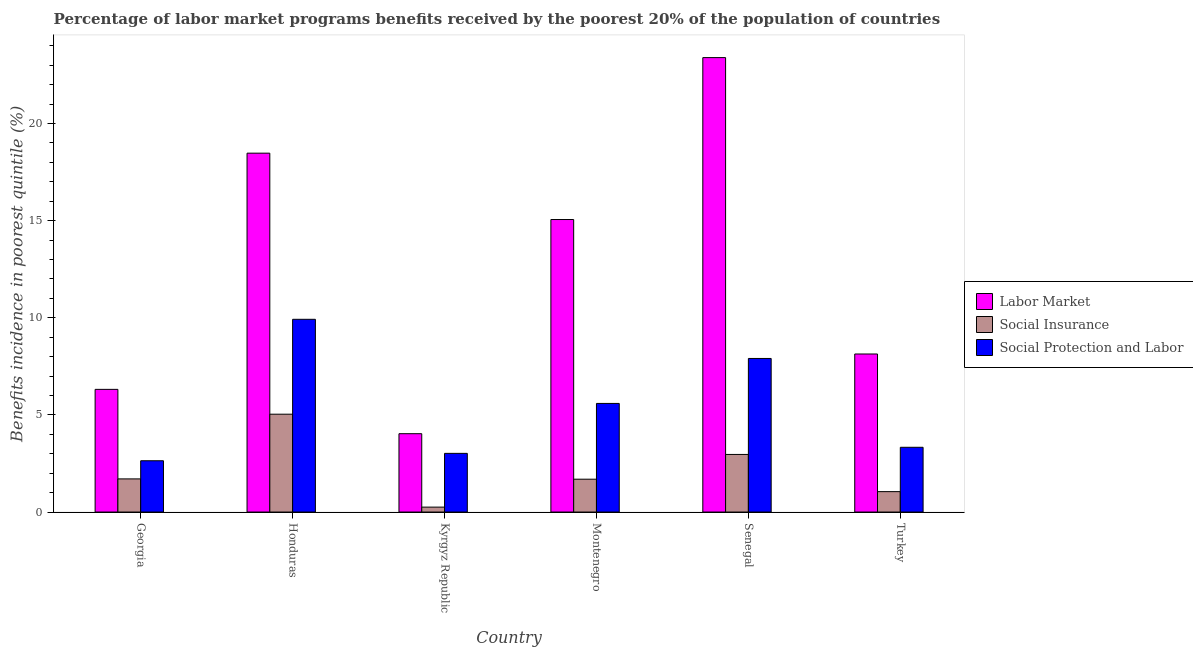Are the number of bars per tick equal to the number of legend labels?
Make the answer very short. Yes. Are the number of bars on each tick of the X-axis equal?
Keep it short and to the point. Yes. How many bars are there on the 5th tick from the right?
Keep it short and to the point. 3. What is the label of the 3rd group of bars from the left?
Offer a terse response. Kyrgyz Republic. In how many cases, is the number of bars for a given country not equal to the number of legend labels?
Ensure brevity in your answer.  0. What is the percentage of benefits received due to social protection programs in Montenegro?
Give a very brief answer. 5.59. Across all countries, what is the maximum percentage of benefits received due to labor market programs?
Offer a terse response. 23.39. Across all countries, what is the minimum percentage of benefits received due to social protection programs?
Give a very brief answer. 2.64. In which country was the percentage of benefits received due to labor market programs maximum?
Your answer should be very brief. Senegal. In which country was the percentage of benefits received due to social insurance programs minimum?
Provide a short and direct response. Kyrgyz Republic. What is the total percentage of benefits received due to labor market programs in the graph?
Keep it short and to the point. 75.39. What is the difference between the percentage of benefits received due to social insurance programs in Georgia and that in Senegal?
Your response must be concise. -1.26. What is the difference between the percentage of benefits received due to labor market programs in Georgia and the percentage of benefits received due to social protection programs in Kyrgyz Republic?
Offer a terse response. 3.29. What is the average percentage of benefits received due to social protection programs per country?
Ensure brevity in your answer.  5.4. What is the difference between the percentage of benefits received due to labor market programs and percentage of benefits received due to social protection programs in Honduras?
Your answer should be very brief. 8.55. What is the ratio of the percentage of benefits received due to social insurance programs in Honduras to that in Turkey?
Offer a terse response. 4.8. Is the percentage of benefits received due to labor market programs in Montenegro less than that in Senegal?
Give a very brief answer. Yes. What is the difference between the highest and the second highest percentage of benefits received due to labor market programs?
Your answer should be very brief. 4.92. What is the difference between the highest and the lowest percentage of benefits received due to social protection programs?
Your response must be concise. 7.28. What does the 1st bar from the left in Honduras represents?
Offer a very short reply. Labor Market. What does the 3rd bar from the right in Kyrgyz Republic represents?
Provide a short and direct response. Labor Market. Is it the case that in every country, the sum of the percentage of benefits received due to labor market programs and percentage of benefits received due to social insurance programs is greater than the percentage of benefits received due to social protection programs?
Give a very brief answer. Yes. How many countries are there in the graph?
Provide a succinct answer. 6. Are the values on the major ticks of Y-axis written in scientific E-notation?
Offer a terse response. No. Does the graph contain any zero values?
Provide a succinct answer. No. Does the graph contain grids?
Provide a succinct answer. No. Where does the legend appear in the graph?
Offer a terse response. Center right. How are the legend labels stacked?
Provide a short and direct response. Vertical. What is the title of the graph?
Provide a short and direct response. Percentage of labor market programs benefits received by the poorest 20% of the population of countries. Does "Agriculture" appear as one of the legend labels in the graph?
Provide a short and direct response. No. What is the label or title of the X-axis?
Your answer should be very brief. Country. What is the label or title of the Y-axis?
Give a very brief answer. Benefits incidence in poorest quintile (%). What is the Benefits incidence in poorest quintile (%) of Labor Market in Georgia?
Give a very brief answer. 6.31. What is the Benefits incidence in poorest quintile (%) of Social Insurance in Georgia?
Make the answer very short. 1.71. What is the Benefits incidence in poorest quintile (%) in Social Protection and Labor in Georgia?
Offer a terse response. 2.64. What is the Benefits incidence in poorest quintile (%) in Labor Market in Honduras?
Ensure brevity in your answer.  18.47. What is the Benefits incidence in poorest quintile (%) in Social Insurance in Honduras?
Make the answer very short. 5.04. What is the Benefits incidence in poorest quintile (%) of Social Protection and Labor in Honduras?
Ensure brevity in your answer.  9.92. What is the Benefits incidence in poorest quintile (%) of Labor Market in Kyrgyz Republic?
Your answer should be compact. 4.03. What is the Benefits incidence in poorest quintile (%) in Social Insurance in Kyrgyz Republic?
Your response must be concise. 0.25. What is the Benefits incidence in poorest quintile (%) in Social Protection and Labor in Kyrgyz Republic?
Ensure brevity in your answer.  3.02. What is the Benefits incidence in poorest quintile (%) of Labor Market in Montenegro?
Keep it short and to the point. 15.05. What is the Benefits incidence in poorest quintile (%) in Social Insurance in Montenegro?
Your answer should be very brief. 1.69. What is the Benefits incidence in poorest quintile (%) of Social Protection and Labor in Montenegro?
Your answer should be compact. 5.59. What is the Benefits incidence in poorest quintile (%) of Labor Market in Senegal?
Keep it short and to the point. 23.39. What is the Benefits incidence in poorest quintile (%) of Social Insurance in Senegal?
Your response must be concise. 2.96. What is the Benefits incidence in poorest quintile (%) of Social Protection and Labor in Senegal?
Your answer should be very brief. 7.9. What is the Benefits incidence in poorest quintile (%) in Labor Market in Turkey?
Provide a succinct answer. 8.13. What is the Benefits incidence in poorest quintile (%) of Social Insurance in Turkey?
Ensure brevity in your answer.  1.05. What is the Benefits incidence in poorest quintile (%) of Social Protection and Labor in Turkey?
Your answer should be very brief. 3.33. Across all countries, what is the maximum Benefits incidence in poorest quintile (%) in Labor Market?
Make the answer very short. 23.39. Across all countries, what is the maximum Benefits incidence in poorest quintile (%) of Social Insurance?
Make the answer very short. 5.04. Across all countries, what is the maximum Benefits incidence in poorest quintile (%) of Social Protection and Labor?
Provide a short and direct response. 9.92. Across all countries, what is the minimum Benefits incidence in poorest quintile (%) in Labor Market?
Your answer should be compact. 4.03. Across all countries, what is the minimum Benefits incidence in poorest quintile (%) of Social Insurance?
Provide a short and direct response. 0.25. Across all countries, what is the minimum Benefits incidence in poorest quintile (%) of Social Protection and Labor?
Offer a very short reply. 2.64. What is the total Benefits incidence in poorest quintile (%) in Labor Market in the graph?
Provide a succinct answer. 75.39. What is the total Benefits incidence in poorest quintile (%) in Social Insurance in the graph?
Keep it short and to the point. 12.7. What is the total Benefits incidence in poorest quintile (%) in Social Protection and Labor in the graph?
Give a very brief answer. 32.4. What is the difference between the Benefits incidence in poorest quintile (%) in Labor Market in Georgia and that in Honduras?
Your answer should be very brief. -12.16. What is the difference between the Benefits incidence in poorest quintile (%) in Social Insurance in Georgia and that in Honduras?
Your answer should be compact. -3.33. What is the difference between the Benefits incidence in poorest quintile (%) in Social Protection and Labor in Georgia and that in Honduras?
Ensure brevity in your answer.  -7.28. What is the difference between the Benefits incidence in poorest quintile (%) of Labor Market in Georgia and that in Kyrgyz Republic?
Offer a very short reply. 2.28. What is the difference between the Benefits incidence in poorest quintile (%) of Social Insurance in Georgia and that in Kyrgyz Republic?
Offer a very short reply. 1.45. What is the difference between the Benefits incidence in poorest quintile (%) of Social Protection and Labor in Georgia and that in Kyrgyz Republic?
Provide a succinct answer. -0.38. What is the difference between the Benefits incidence in poorest quintile (%) in Labor Market in Georgia and that in Montenegro?
Your answer should be very brief. -8.74. What is the difference between the Benefits incidence in poorest quintile (%) in Social Insurance in Georgia and that in Montenegro?
Provide a short and direct response. 0.02. What is the difference between the Benefits incidence in poorest quintile (%) in Social Protection and Labor in Georgia and that in Montenegro?
Give a very brief answer. -2.95. What is the difference between the Benefits incidence in poorest quintile (%) of Labor Market in Georgia and that in Senegal?
Provide a succinct answer. -17.07. What is the difference between the Benefits incidence in poorest quintile (%) in Social Insurance in Georgia and that in Senegal?
Ensure brevity in your answer.  -1.26. What is the difference between the Benefits incidence in poorest quintile (%) in Social Protection and Labor in Georgia and that in Senegal?
Provide a succinct answer. -5.26. What is the difference between the Benefits incidence in poorest quintile (%) in Labor Market in Georgia and that in Turkey?
Provide a short and direct response. -1.82. What is the difference between the Benefits incidence in poorest quintile (%) in Social Insurance in Georgia and that in Turkey?
Your answer should be very brief. 0.66. What is the difference between the Benefits incidence in poorest quintile (%) of Social Protection and Labor in Georgia and that in Turkey?
Keep it short and to the point. -0.69. What is the difference between the Benefits incidence in poorest quintile (%) in Labor Market in Honduras and that in Kyrgyz Republic?
Ensure brevity in your answer.  14.44. What is the difference between the Benefits incidence in poorest quintile (%) of Social Insurance in Honduras and that in Kyrgyz Republic?
Provide a short and direct response. 4.78. What is the difference between the Benefits incidence in poorest quintile (%) in Social Protection and Labor in Honduras and that in Kyrgyz Republic?
Offer a very short reply. 6.9. What is the difference between the Benefits incidence in poorest quintile (%) in Labor Market in Honduras and that in Montenegro?
Your response must be concise. 3.42. What is the difference between the Benefits incidence in poorest quintile (%) of Social Insurance in Honduras and that in Montenegro?
Ensure brevity in your answer.  3.35. What is the difference between the Benefits incidence in poorest quintile (%) in Social Protection and Labor in Honduras and that in Montenegro?
Your response must be concise. 4.33. What is the difference between the Benefits incidence in poorest quintile (%) of Labor Market in Honduras and that in Senegal?
Make the answer very short. -4.92. What is the difference between the Benefits incidence in poorest quintile (%) of Social Insurance in Honduras and that in Senegal?
Give a very brief answer. 2.07. What is the difference between the Benefits incidence in poorest quintile (%) of Social Protection and Labor in Honduras and that in Senegal?
Offer a terse response. 2.02. What is the difference between the Benefits incidence in poorest quintile (%) of Labor Market in Honduras and that in Turkey?
Offer a very short reply. 10.34. What is the difference between the Benefits incidence in poorest quintile (%) of Social Insurance in Honduras and that in Turkey?
Offer a terse response. 3.99. What is the difference between the Benefits incidence in poorest quintile (%) of Social Protection and Labor in Honduras and that in Turkey?
Your answer should be compact. 6.59. What is the difference between the Benefits incidence in poorest quintile (%) in Labor Market in Kyrgyz Republic and that in Montenegro?
Offer a very short reply. -11.02. What is the difference between the Benefits incidence in poorest quintile (%) of Social Insurance in Kyrgyz Republic and that in Montenegro?
Your answer should be very brief. -1.44. What is the difference between the Benefits incidence in poorest quintile (%) in Social Protection and Labor in Kyrgyz Republic and that in Montenegro?
Offer a terse response. -2.57. What is the difference between the Benefits incidence in poorest quintile (%) of Labor Market in Kyrgyz Republic and that in Senegal?
Your answer should be compact. -19.36. What is the difference between the Benefits incidence in poorest quintile (%) in Social Insurance in Kyrgyz Republic and that in Senegal?
Give a very brief answer. -2.71. What is the difference between the Benefits incidence in poorest quintile (%) of Social Protection and Labor in Kyrgyz Republic and that in Senegal?
Your answer should be very brief. -4.88. What is the difference between the Benefits incidence in poorest quintile (%) in Labor Market in Kyrgyz Republic and that in Turkey?
Offer a terse response. -4.1. What is the difference between the Benefits incidence in poorest quintile (%) of Social Insurance in Kyrgyz Republic and that in Turkey?
Offer a very short reply. -0.8. What is the difference between the Benefits incidence in poorest quintile (%) in Social Protection and Labor in Kyrgyz Republic and that in Turkey?
Provide a succinct answer. -0.31. What is the difference between the Benefits incidence in poorest quintile (%) of Labor Market in Montenegro and that in Senegal?
Offer a terse response. -8.33. What is the difference between the Benefits incidence in poorest quintile (%) of Social Insurance in Montenegro and that in Senegal?
Keep it short and to the point. -1.27. What is the difference between the Benefits incidence in poorest quintile (%) in Social Protection and Labor in Montenegro and that in Senegal?
Keep it short and to the point. -2.31. What is the difference between the Benefits incidence in poorest quintile (%) of Labor Market in Montenegro and that in Turkey?
Offer a terse response. 6.92. What is the difference between the Benefits incidence in poorest quintile (%) of Social Insurance in Montenegro and that in Turkey?
Offer a terse response. 0.64. What is the difference between the Benefits incidence in poorest quintile (%) in Social Protection and Labor in Montenegro and that in Turkey?
Give a very brief answer. 2.26. What is the difference between the Benefits incidence in poorest quintile (%) of Labor Market in Senegal and that in Turkey?
Your answer should be very brief. 15.26. What is the difference between the Benefits incidence in poorest quintile (%) in Social Insurance in Senegal and that in Turkey?
Offer a very short reply. 1.91. What is the difference between the Benefits incidence in poorest quintile (%) in Social Protection and Labor in Senegal and that in Turkey?
Your response must be concise. 4.57. What is the difference between the Benefits incidence in poorest quintile (%) in Labor Market in Georgia and the Benefits incidence in poorest quintile (%) in Social Insurance in Honduras?
Offer a terse response. 1.28. What is the difference between the Benefits incidence in poorest quintile (%) in Labor Market in Georgia and the Benefits incidence in poorest quintile (%) in Social Protection and Labor in Honduras?
Your answer should be very brief. -3.61. What is the difference between the Benefits incidence in poorest quintile (%) of Social Insurance in Georgia and the Benefits incidence in poorest quintile (%) of Social Protection and Labor in Honduras?
Make the answer very short. -8.21. What is the difference between the Benefits incidence in poorest quintile (%) in Labor Market in Georgia and the Benefits incidence in poorest quintile (%) in Social Insurance in Kyrgyz Republic?
Give a very brief answer. 6.06. What is the difference between the Benefits incidence in poorest quintile (%) in Labor Market in Georgia and the Benefits incidence in poorest quintile (%) in Social Protection and Labor in Kyrgyz Republic?
Give a very brief answer. 3.29. What is the difference between the Benefits incidence in poorest quintile (%) in Social Insurance in Georgia and the Benefits incidence in poorest quintile (%) in Social Protection and Labor in Kyrgyz Republic?
Your response must be concise. -1.31. What is the difference between the Benefits incidence in poorest quintile (%) of Labor Market in Georgia and the Benefits incidence in poorest quintile (%) of Social Insurance in Montenegro?
Your answer should be very brief. 4.62. What is the difference between the Benefits incidence in poorest quintile (%) in Labor Market in Georgia and the Benefits incidence in poorest quintile (%) in Social Protection and Labor in Montenegro?
Give a very brief answer. 0.72. What is the difference between the Benefits incidence in poorest quintile (%) of Social Insurance in Georgia and the Benefits incidence in poorest quintile (%) of Social Protection and Labor in Montenegro?
Keep it short and to the point. -3.88. What is the difference between the Benefits incidence in poorest quintile (%) in Labor Market in Georgia and the Benefits incidence in poorest quintile (%) in Social Insurance in Senegal?
Your response must be concise. 3.35. What is the difference between the Benefits incidence in poorest quintile (%) in Labor Market in Georgia and the Benefits incidence in poorest quintile (%) in Social Protection and Labor in Senegal?
Ensure brevity in your answer.  -1.59. What is the difference between the Benefits incidence in poorest quintile (%) of Social Insurance in Georgia and the Benefits incidence in poorest quintile (%) of Social Protection and Labor in Senegal?
Your response must be concise. -6.2. What is the difference between the Benefits incidence in poorest quintile (%) in Labor Market in Georgia and the Benefits incidence in poorest quintile (%) in Social Insurance in Turkey?
Keep it short and to the point. 5.26. What is the difference between the Benefits incidence in poorest quintile (%) of Labor Market in Georgia and the Benefits incidence in poorest quintile (%) of Social Protection and Labor in Turkey?
Give a very brief answer. 2.98. What is the difference between the Benefits incidence in poorest quintile (%) in Social Insurance in Georgia and the Benefits incidence in poorest quintile (%) in Social Protection and Labor in Turkey?
Keep it short and to the point. -1.63. What is the difference between the Benefits incidence in poorest quintile (%) in Labor Market in Honduras and the Benefits incidence in poorest quintile (%) in Social Insurance in Kyrgyz Republic?
Your answer should be compact. 18.22. What is the difference between the Benefits incidence in poorest quintile (%) of Labor Market in Honduras and the Benefits incidence in poorest quintile (%) of Social Protection and Labor in Kyrgyz Republic?
Offer a terse response. 15.45. What is the difference between the Benefits incidence in poorest quintile (%) in Social Insurance in Honduras and the Benefits incidence in poorest quintile (%) in Social Protection and Labor in Kyrgyz Republic?
Provide a succinct answer. 2.02. What is the difference between the Benefits incidence in poorest quintile (%) in Labor Market in Honduras and the Benefits incidence in poorest quintile (%) in Social Insurance in Montenegro?
Ensure brevity in your answer.  16.78. What is the difference between the Benefits incidence in poorest quintile (%) of Labor Market in Honduras and the Benefits incidence in poorest quintile (%) of Social Protection and Labor in Montenegro?
Provide a succinct answer. 12.88. What is the difference between the Benefits incidence in poorest quintile (%) of Social Insurance in Honduras and the Benefits incidence in poorest quintile (%) of Social Protection and Labor in Montenegro?
Offer a terse response. -0.55. What is the difference between the Benefits incidence in poorest quintile (%) of Labor Market in Honduras and the Benefits incidence in poorest quintile (%) of Social Insurance in Senegal?
Provide a succinct answer. 15.51. What is the difference between the Benefits incidence in poorest quintile (%) in Labor Market in Honduras and the Benefits incidence in poorest quintile (%) in Social Protection and Labor in Senegal?
Your answer should be compact. 10.57. What is the difference between the Benefits incidence in poorest quintile (%) of Social Insurance in Honduras and the Benefits incidence in poorest quintile (%) of Social Protection and Labor in Senegal?
Keep it short and to the point. -2.87. What is the difference between the Benefits incidence in poorest quintile (%) in Labor Market in Honduras and the Benefits incidence in poorest quintile (%) in Social Insurance in Turkey?
Keep it short and to the point. 17.42. What is the difference between the Benefits incidence in poorest quintile (%) of Labor Market in Honduras and the Benefits incidence in poorest quintile (%) of Social Protection and Labor in Turkey?
Your answer should be compact. 15.14. What is the difference between the Benefits incidence in poorest quintile (%) in Social Insurance in Honduras and the Benefits incidence in poorest quintile (%) in Social Protection and Labor in Turkey?
Provide a short and direct response. 1.7. What is the difference between the Benefits incidence in poorest quintile (%) of Labor Market in Kyrgyz Republic and the Benefits incidence in poorest quintile (%) of Social Insurance in Montenegro?
Your response must be concise. 2.34. What is the difference between the Benefits incidence in poorest quintile (%) of Labor Market in Kyrgyz Republic and the Benefits incidence in poorest quintile (%) of Social Protection and Labor in Montenegro?
Your answer should be compact. -1.56. What is the difference between the Benefits incidence in poorest quintile (%) of Social Insurance in Kyrgyz Republic and the Benefits incidence in poorest quintile (%) of Social Protection and Labor in Montenegro?
Your answer should be compact. -5.34. What is the difference between the Benefits incidence in poorest quintile (%) in Labor Market in Kyrgyz Republic and the Benefits incidence in poorest quintile (%) in Social Insurance in Senegal?
Your answer should be very brief. 1.07. What is the difference between the Benefits incidence in poorest quintile (%) of Labor Market in Kyrgyz Republic and the Benefits incidence in poorest quintile (%) of Social Protection and Labor in Senegal?
Provide a short and direct response. -3.87. What is the difference between the Benefits incidence in poorest quintile (%) in Social Insurance in Kyrgyz Republic and the Benefits incidence in poorest quintile (%) in Social Protection and Labor in Senegal?
Offer a very short reply. -7.65. What is the difference between the Benefits incidence in poorest quintile (%) in Labor Market in Kyrgyz Republic and the Benefits incidence in poorest quintile (%) in Social Insurance in Turkey?
Provide a succinct answer. 2.98. What is the difference between the Benefits incidence in poorest quintile (%) of Labor Market in Kyrgyz Republic and the Benefits incidence in poorest quintile (%) of Social Protection and Labor in Turkey?
Your response must be concise. 0.7. What is the difference between the Benefits incidence in poorest quintile (%) in Social Insurance in Kyrgyz Republic and the Benefits incidence in poorest quintile (%) in Social Protection and Labor in Turkey?
Provide a succinct answer. -3.08. What is the difference between the Benefits incidence in poorest quintile (%) in Labor Market in Montenegro and the Benefits incidence in poorest quintile (%) in Social Insurance in Senegal?
Your answer should be very brief. 12.09. What is the difference between the Benefits incidence in poorest quintile (%) of Labor Market in Montenegro and the Benefits incidence in poorest quintile (%) of Social Protection and Labor in Senegal?
Keep it short and to the point. 7.15. What is the difference between the Benefits incidence in poorest quintile (%) of Social Insurance in Montenegro and the Benefits incidence in poorest quintile (%) of Social Protection and Labor in Senegal?
Your response must be concise. -6.21. What is the difference between the Benefits incidence in poorest quintile (%) of Labor Market in Montenegro and the Benefits incidence in poorest quintile (%) of Social Insurance in Turkey?
Ensure brevity in your answer.  14.01. What is the difference between the Benefits incidence in poorest quintile (%) in Labor Market in Montenegro and the Benefits incidence in poorest quintile (%) in Social Protection and Labor in Turkey?
Ensure brevity in your answer.  11.72. What is the difference between the Benefits incidence in poorest quintile (%) in Social Insurance in Montenegro and the Benefits incidence in poorest quintile (%) in Social Protection and Labor in Turkey?
Provide a short and direct response. -1.64. What is the difference between the Benefits incidence in poorest quintile (%) of Labor Market in Senegal and the Benefits incidence in poorest quintile (%) of Social Insurance in Turkey?
Your answer should be compact. 22.34. What is the difference between the Benefits incidence in poorest quintile (%) in Labor Market in Senegal and the Benefits incidence in poorest quintile (%) in Social Protection and Labor in Turkey?
Offer a very short reply. 20.06. What is the difference between the Benefits incidence in poorest quintile (%) of Social Insurance in Senegal and the Benefits incidence in poorest quintile (%) of Social Protection and Labor in Turkey?
Provide a succinct answer. -0.37. What is the average Benefits incidence in poorest quintile (%) in Labor Market per country?
Offer a terse response. 12.57. What is the average Benefits incidence in poorest quintile (%) of Social Insurance per country?
Offer a terse response. 2.12. What is the average Benefits incidence in poorest quintile (%) in Social Protection and Labor per country?
Make the answer very short. 5.4. What is the difference between the Benefits incidence in poorest quintile (%) of Labor Market and Benefits incidence in poorest quintile (%) of Social Insurance in Georgia?
Your answer should be compact. 4.61. What is the difference between the Benefits incidence in poorest quintile (%) of Labor Market and Benefits incidence in poorest quintile (%) of Social Protection and Labor in Georgia?
Make the answer very short. 3.67. What is the difference between the Benefits incidence in poorest quintile (%) of Social Insurance and Benefits incidence in poorest quintile (%) of Social Protection and Labor in Georgia?
Provide a succinct answer. -0.93. What is the difference between the Benefits incidence in poorest quintile (%) of Labor Market and Benefits incidence in poorest quintile (%) of Social Insurance in Honduras?
Your response must be concise. 13.44. What is the difference between the Benefits incidence in poorest quintile (%) in Labor Market and Benefits incidence in poorest quintile (%) in Social Protection and Labor in Honduras?
Provide a succinct answer. 8.55. What is the difference between the Benefits incidence in poorest quintile (%) of Social Insurance and Benefits incidence in poorest quintile (%) of Social Protection and Labor in Honduras?
Your response must be concise. -4.88. What is the difference between the Benefits incidence in poorest quintile (%) in Labor Market and Benefits incidence in poorest quintile (%) in Social Insurance in Kyrgyz Republic?
Your answer should be very brief. 3.78. What is the difference between the Benefits incidence in poorest quintile (%) of Labor Market and Benefits incidence in poorest quintile (%) of Social Protection and Labor in Kyrgyz Republic?
Provide a short and direct response. 1.01. What is the difference between the Benefits incidence in poorest quintile (%) of Social Insurance and Benefits incidence in poorest quintile (%) of Social Protection and Labor in Kyrgyz Republic?
Your response must be concise. -2.77. What is the difference between the Benefits incidence in poorest quintile (%) in Labor Market and Benefits incidence in poorest quintile (%) in Social Insurance in Montenegro?
Your answer should be compact. 13.36. What is the difference between the Benefits incidence in poorest quintile (%) in Labor Market and Benefits incidence in poorest quintile (%) in Social Protection and Labor in Montenegro?
Your response must be concise. 9.46. What is the difference between the Benefits incidence in poorest quintile (%) of Social Insurance and Benefits incidence in poorest quintile (%) of Social Protection and Labor in Montenegro?
Your answer should be very brief. -3.9. What is the difference between the Benefits incidence in poorest quintile (%) of Labor Market and Benefits incidence in poorest quintile (%) of Social Insurance in Senegal?
Provide a short and direct response. 20.43. What is the difference between the Benefits incidence in poorest quintile (%) in Labor Market and Benefits incidence in poorest quintile (%) in Social Protection and Labor in Senegal?
Your answer should be compact. 15.48. What is the difference between the Benefits incidence in poorest quintile (%) in Social Insurance and Benefits incidence in poorest quintile (%) in Social Protection and Labor in Senegal?
Your response must be concise. -4.94. What is the difference between the Benefits incidence in poorest quintile (%) in Labor Market and Benefits incidence in poorest quintile (%) in Social Insurance in Turkey?
Keep it short and to the point. 7.08. What is the difference between the Benefits incidence in poorest quintile (%) of Labor Market and Benefits incidence in poorest quintile (%) of Social Protection and Labor in Turkey?
Provide a short and direct response. 4.8. What is the difference between the Benefits incidence in poorest quintile (%) of Social Insurance and Benefits incidence in poorest quintile (%) of Social Protection and Labor in Turkey?
Your answer should be compact. -2.28. What is the ratio of the Benefits incidence in poorest quintile (%) in Labor Market in Georgia to that in Honduras?
Your answer should be compact. 0.34. What is the ratio of the Benefits incidence in poorest quintile (%) in Social Insurance in Georgia to that in Honduras?
Make the answer very short. 0.34. What is the ratio of the Benefits incidence in poorest quintile (%) of Social Protection and Labor in Georgia to that in Honduras?
Ensure brevity in your answer.  0.27. What is the ratio of the Benefits incidence in poorest quintile (%) of Labor Market in Georgia to that in Kyrgyz Republic?
Offer a very short reply. 1.57. What is the ratio of the Benefits incidence in poorest quintile (%) in Social Insurance in Georgia to that in Kyrgyz Republic?
Make the answer very short. 6.73. What is the ratio of the Benefits incidence in poorest quintile (%) of Social Protection and Labor in Georgia to that in Kyrgyz Republic?
Offer a very short reply. 0.87. What is the ratio of the Benefits incidence in poorest quintile (%) of Labor Market in Georgia to that in Montenegro?
Offer a very short reply. 0.42. What is the ratio of the Benefits incidence in poorest quintile (%) of Social Insurance in Georgia to that in Montenegro?
Give a very brief answer. 1.01. What is the ratio of the Benefits incidence in poorest quintile (%) of Social Protection and Labor in Georgia to that in Montenegro?
Ensure brevity in your answer.  0.47. What is the ratio of the Benefits incidence in poorest quintile (%) of Labor Market in Georgia to that in Senegal?
Offer a very short reply. 0.27. What is the ratio of the Benefits incidence in poorest quintile (%) of Social Insurance in Georgia to that in Senegal?
Offer a very short reply. 0.58. What is the ratio of the Benefits incidence in poorest quintile (%) of Social Protection and Labor in Georgia to that in Senegal?
Offer a terse response. 0.33. What is the ratio of the Benefits incidence in poorest quintile (%) in Labor Market in Georgia to that in Turkey?
Your answer should be very brief. 0.78. What is the ratio of the Benefits incidence in poorest quintile (%) in Social Insurance in Georgia to that in Turkey?
Give a very brief answer. 1.62. What is the ratio of the Benefits incidence in poorest quintile (%) in Social Protection and Labor in Georgia to that in Turkey?
Your answer should be very brief. 0.79. What is the ratio of the Benefits incidence in poorest quintile (%) of Labor Market in Honduras to that in Kyrgyz Republic?
Give a very brief answer. 4.58. What is the ratio of the Benefits incidence in poorest quintile (%) of Social Insurance in Honduras to that in Kyrgyz Republic?
Your response must be concise. 19.87. What is the ratio of the Benefits incidence in poorest quintile (%) of Social Protection and Labor in Honduras to that in Kyrgyz Republic?
Provide a succinct answer. 3.29. What is the ratio of the Benefits incidence in poorest quintile (%) in Labor Market in Honduras to that in Montenegro?
Your answer should be very brief. 1.23. What is the ratio of the Benefits incidence in poorest quintile (%) in Social Insurance in Honduras to that in Montenegro?
Provide a short and direct response. 2.98. What is the ratio of the Benefits incidence in poorest quintile (%) in Social Protection and Labor in Honduras to that in Montenegro?
Offer a very short reply. 1.77. What is the ratio of the Benefits incidence in poorest quintile (%) of Labor Market in Honduras to that in Senegal?
Your answer should be compact. 0.79. What is the ratio of the Benefits incidence in poorest quintile (%) of Social Insurance in Honduras to that in Senegal?
Provide a succinct answer. 1.7. What is the ratio of the Benefits incidence in poorest quintile (%) of Social Protection and Labor in Honduras to that in Senegal?
Offer a very short reply. 1.25. What is the ratio of the Benefits incidence in poorest quintile (%) of Labor Market in Honduras to that in Turkey?
Provide a short and direct response. 2.27. What is the ratio of the Benefits incidence in poorest quintile (%) in Social Insurance in Honduras to that in Turkey?
Your response must be concise. 4.8. What is the ratio of the Benefits incidence in poorest quintile (%) of Social Protection and Labor in Honduras to that in Turkey?
Your answer should be compact. 2.98. What is the ratio of the Benefits incidence in poorest quintile (%) in Labor Market in Kyrgyz Republic to that in Montenegro?
Your response must be concise. 0.27. What is the ratio of the Benefits incidence in poorest quintile (%) of Social Insurance in Kyrgyz Republic to that in Montenegro?
Offer a terse response. 0.15. What is the ratio of the Benefits incidence in poorest quintile (%) of Social Protection and Labor in Kyrgyz Republic to that in Montenegro?
Give a very brief answer. 0.54. What is the ratio of the Benefits incidence in poorest quintile (%) of Labor Market in Kyrgyz Republic to that in Senegal?
Offer a very short reply. 0.17. What is the ratio of the Benefits incidence in poorest quintile (%) in Social Insurance in Kyrgyz Republic to that in Senegal?
Provide a succinct answer. 0.09. What is the ratio of the Benefits incidence in poorest quintile (%) of Social Protection and Labor in Kyrgyz Republic to that in Senegal?
Offer a terse response. 0.38. What is the ratio of the Benefits incidence in poorest quintile (%) of Labor Market in Kyrgyz Republic to that in Turkey?
Provide a succinct answer. 0.5. What is the ratio of the Benefits incidence in poorest quintile (%) of Social Insurance in Kyrgyz Republic to that in Turkey?
Your answer should be compact. 0.24. What is the ratio of the Benefits incidence in poorest quintile (%) of Social Protection and Labor in Kyrgyz Republic to that in Turkey?
Your answer should be very brief. 0.91. What is the ratio of the Benefits incidence in poorest quintile (%) of Labor Market in Montenegro to that in Senegal?
Keep it short and to the point. 0.64. What is the ratio of the Benefits incidence in poorest quintile (%) of Social Insurance in Montenegro to that in Senegal?
Provide a succinct answer. 0.57. What is the ratio of the Benefits incidence in poorest quintile (%) in Social Protection and Labor in Montenegro to that in Senegal?
Ensure brevity in your answer.  0.71. What is the ratio of the Benefits incidence in poorest quintile (%) of Labor Market in Montenegro to that in Turkey?
Your response must be concise. 1.85. What is the ratio of the Benefits incidence in poorest quintile (%) in Social Insurance in Montenegro to that in Turkey?
Provide a short and direct response. 1.61. What is the ratio of the Benefits incidence in poorest quintile (%) of Social Protection and Labor in Montenegro to that in Turkey?
Offer a terse response. 1.68. What is the ratio of the Benefits incidence in poorest quintile (%) of Labor Market in Senegal to that in Turkey?
Your response must be concise. 2.88. What is the ratio of the Benefits incidence in poorest quintile (%) of Social Insurance in Senegal to that in Turkey?
Your answer should be compact. 2.82. What is the ratio of the Benefits incidence in poorest quintile (%) of Social Protection and Labor in Senegal to that in Turkey?
Your answer should be compact. 2.37. What is the difference between the highest and the second highest Benefits incidence in poorest quintile (%) in Labor Market?
Your answer should be very brief. 4.92. What is the difference between the highest and the second highest Benefits incidence in poorest quintile (%) of Social Insurance?
Provide a short and direct response. 2.07. What is the difference between the highest and the second highest Benefits incidence in poorest quintile (%) of Social Protection and Labor?
Offer a terse response. 2.02. What is the difference between the highest and the lowest Benefits incidence in poorest quintile (%) in Labor Market?
Your response must be concise. 19.36. What is the difference between the highest and the lowest Benefits incidence in poorest quintile (%) in Social Insurance?
Offer a very short reply. 4.78. What is the difference between the highest and the lowest Benefits incidence in poorest quintile (%) of Social Protection and Labor?
Offer a very short reply. 7.28. 